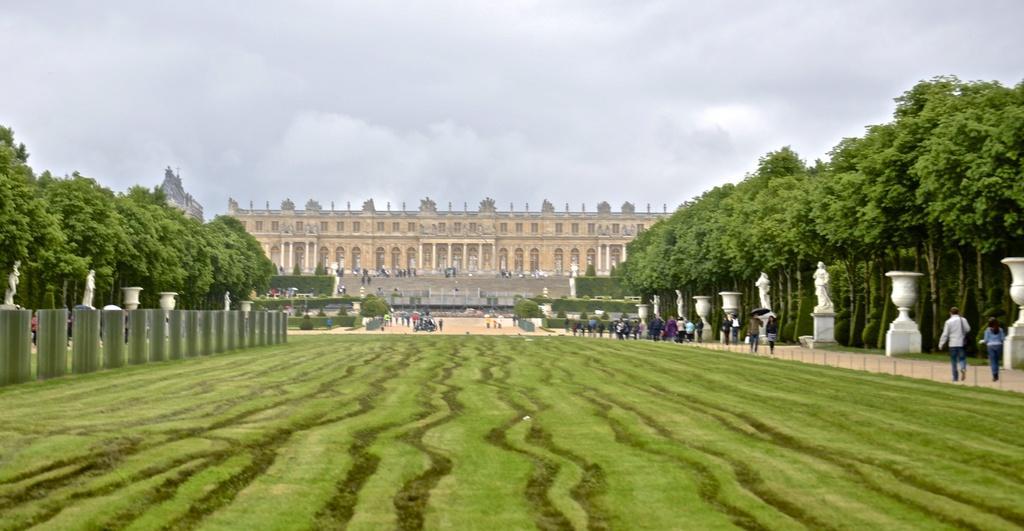Please provide a concise description of this image. In this image, we can see some persons in between sculptures and trees. There is a building in the middle of the image. In the background of the image, there is a sky. 